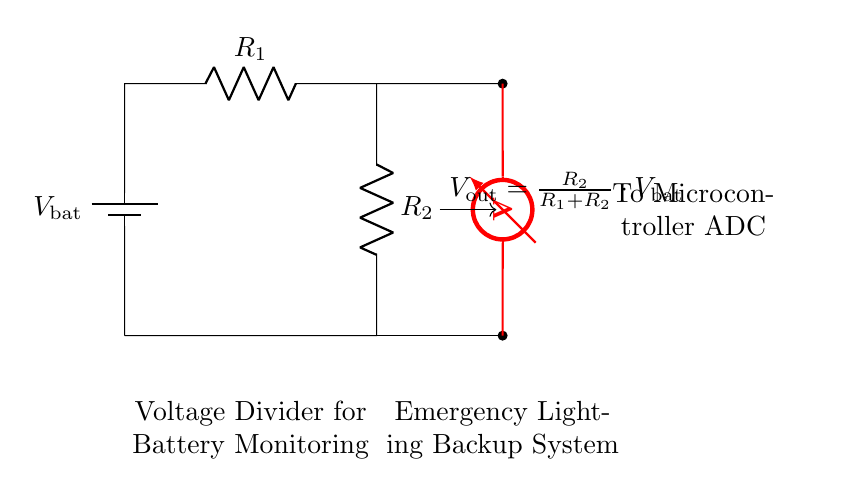What is the purpose of the circuit? The purpose of the circuit is monitoring battery voltage in a backup power system for emergency lighting. This can be inferred from the label in the diagram indicating that it is a voltage divider for battery monitoring, specifically connected to emergency lighting.
Answer: Monitoring battery voltage What are the values of R1 and R2? The circuit diagram does not specify numerical values for R1 and R2; it only labels them as resistors. Consequently, without additional data, we cannot provide exact values.
Answer: Not specified What is the output voltage equation? The equation for the output voltage, as indicated in the circuit diagram, is Vout = R2 / (R1 + R2) * Vbat. This formula expresses how the output voltage is derived from the battery voltage and the resistance values.
Answer: Vout = R2 / (R1 + R2) * Vbat What component is used to measure voltage? The circuit uses a voltmeter to measure the voltage across the output terminals. This is shown in the diagram where the voltmeter is connected from the output of R2 to ground.
Answer: Voltmeter What is Vbat? Vbat refers to the battery voltage, which is the input voltage supplied to the voltage divider. This is indicated at the top of the circuit diagram where the battery is connected to R1.
Answer: Battery voltage If R1 is much larger than R2, what happens to Vout? If R1 is much larger than R2, Vout will be much smaller than Vbat, approaching zero. This is due to the voltage divider rule, where the output voltage depends on the ratio of R2 to the total resistance (R1 + R2).
Answer: Vout approaches zero 